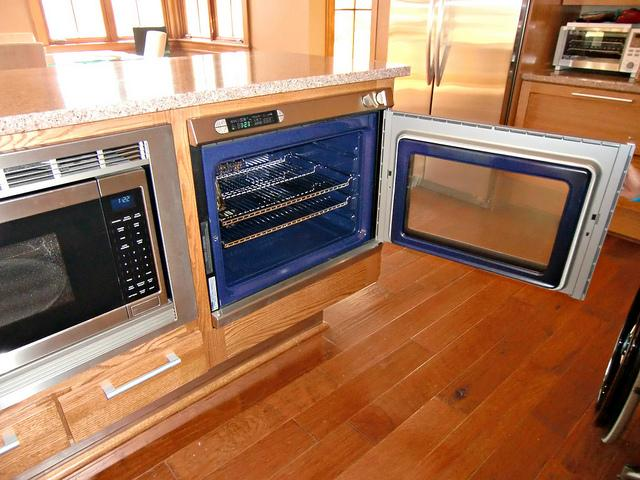What is the state of the blue item? Please explain your reasoning. open. The door is open on it. 